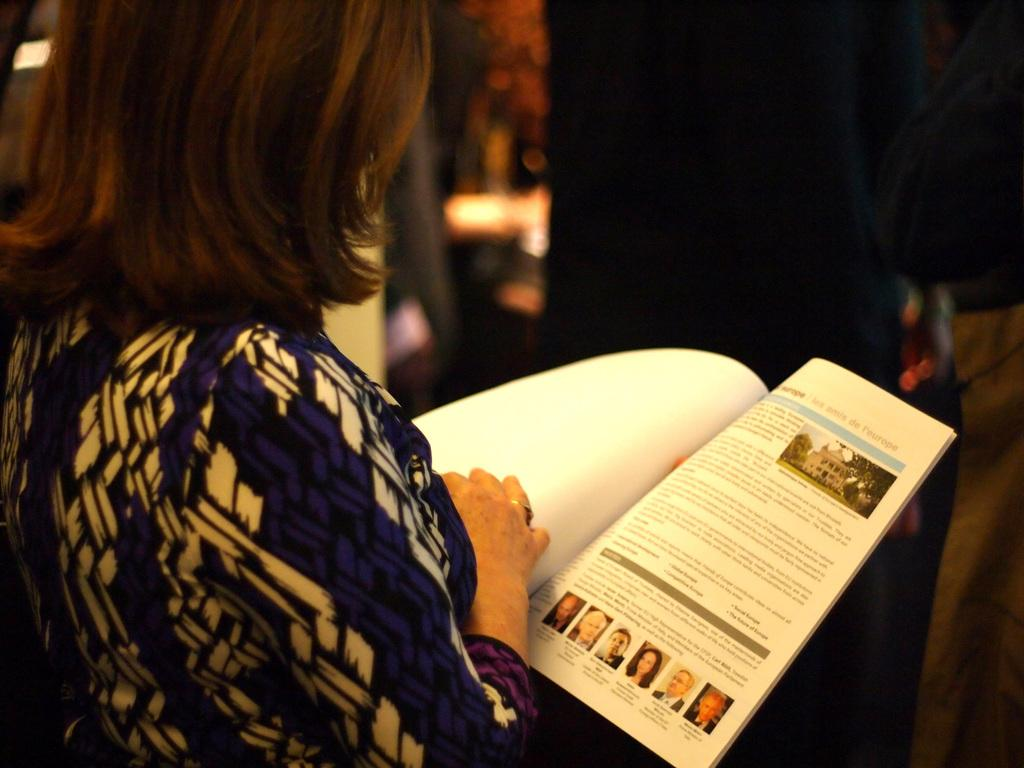Who is the main subject in the image? There is a woman in the image. What is the woman holding in the image? The woman is holding a book. Can you describe the background of the image? There is a blurred image in the background of the image. What type of toys can be seen in the image? There are no toys present in the image. What animal is visible in the image? There is no animal visible in the image. 